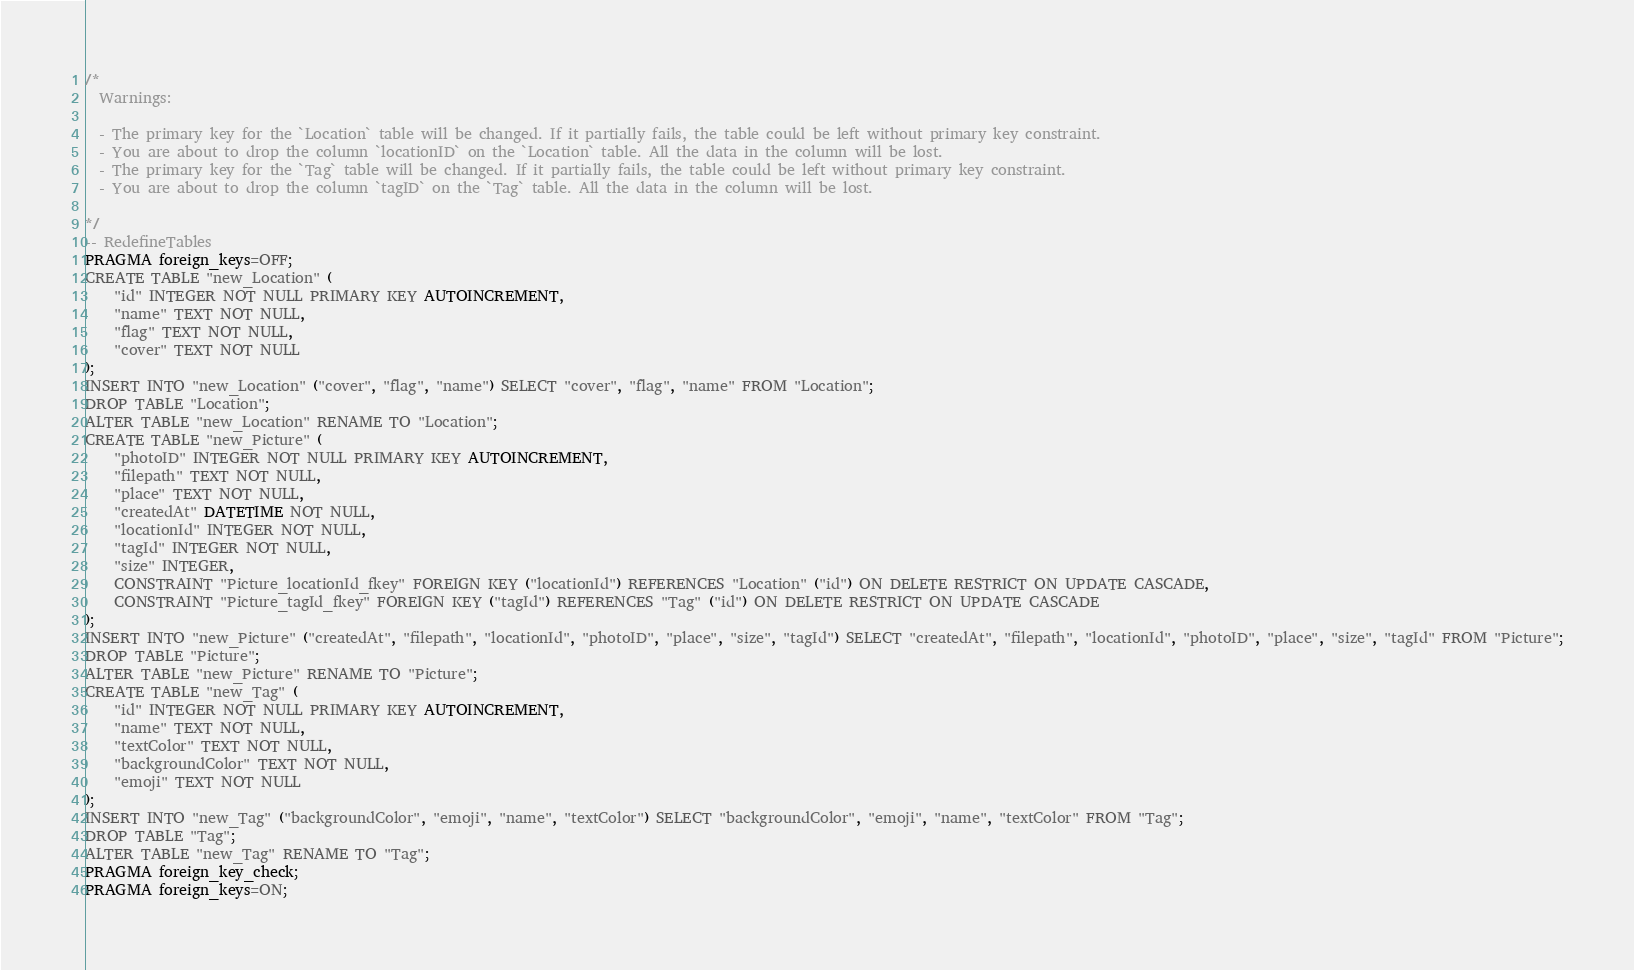<code> <loc_0><loc_0><loc_500><loc_500><_SQL_>/*
  Warnings:

  - The primary key for the `Location` table will be changed. If it partially fails, the table could be left without primary key constraint.
  - You are about to drop the column `locationID` on the `Location` table. All the data in the column will be lost.
  - The primary key for the `Tag` table will be changed. If it partially fails, the table could be left without primary key constraint.
  - You are about to drop the column `tagID` on the `Tag` table. All the data in the column will be lost.

*/
-- RedefineTables
PRAGMA foreign_keys=OFF;
CREATE TABLE "new_Location" (
    "id" INTEGER NOT NULL PRIMARY KEY AUTOINCREMENT,
    "name" TEXT NOT NULL,
    "flag" TEXT NOT NULL,
    "cover" TEXT NOT NULL
);
INSERT INTO "new_Location" ("cover", "flag", "name") SELECT "cover", "flag", "name" FROM "Location";
DROP TABLE "Location";
ALTER TABLE "new_Location" RENAME TO "Location";
CREATE TABLE "new_Picture" (
    "photoID" INTEGER NOT NULL PRIMARY KEY AUTOINCREMENT,
    "filepath" TEXT NOT NULL,
    "place" TEXT NOT NULL,
    "createdAt" DATETIME NOT NULL,
    "locationId" INTEGER NOT NULL,
    "tagId" INTEGER NOT NULL,
    "size" INTEGER,
    CONSTRAINT "Picture_locationId_fkey" FOREIGN KEY ("locationId") REFERENCES "Location" ("id") ON DELETE RESTRICT ON UPDATE CASCADE,
    CONSTRAINT "Picture_tagId_fkey" FOREIGN KEY ("tagId") REFERENCES "Tag" ("id") ON DELETE RESTRICT ON UPDATE CASCADE
);
INSERT INTO "new_Picture" ("createdAt", "filepath", "locationId", "photoID", "place", "size", "tagId") SELECT "createdAt", "filepath", "locationId", "photoID", "place", "size", "tagId" FROM "Picture";
DROP TABLE "Picture";
ALTER TABLE "new_Picture" RENAME TO "Picture";
CREATE TABLE "new_Tag" (
    "id" INTEGER NOT NULL PRIMARY KEY AUTOINCREMENT,
    "name" TEXT NOT NULL,
    "textColor" TEXT NOT NULL,
    "backgroundColor" TEXT NOT NULL,
    "emoji" TEXT NOT NULL
);
INSERT INTO "new_Tag" ("backgroundColor", "emoji", "name", "textColor") SELECT "backgroundColor", "emoji", "name", "textColor" FROM "Tag";
DROP TABLE "Tag";
ALTER TABLE "new_Tag" RENAME TO "Tag";
PRAGMA foreign_key_check;
PRAGMA foreign_keys=ON;
</code> 